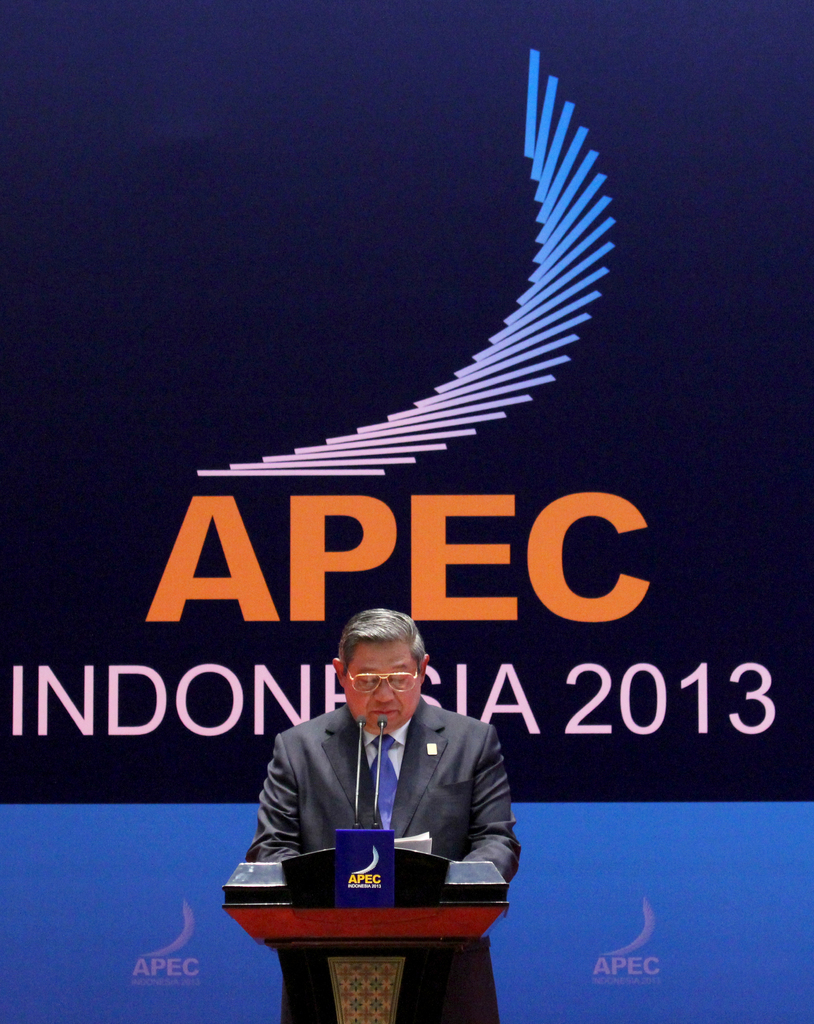What is the significance of the APEC logo displayed on the podium and backdrop? The APEC logo represents the Asia-Pacific Economic Cooperation, which promotes free trade and economic collaboration across the Asia-Pacific region. Its presence at the podium and backdrop signifies the importance of this organization's role in the event and underscores the theme of economic partnership being discussed. 